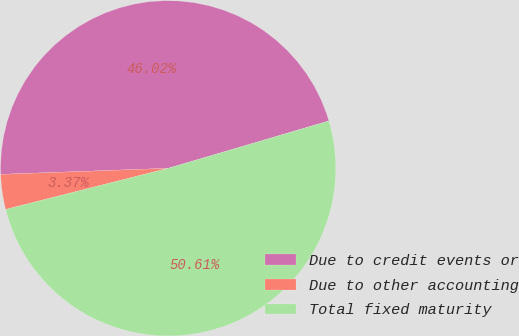Convert chart. <chart><loc_0><loc_0><loc_500><loc_500><pie_chart><fcel>Due to credit events or<fcel>Due to other accounting<fcel>Total fixed maturity<nl><fcel>46.02%<fcel>3.37%<fcel>50.62%<nl></chart> 